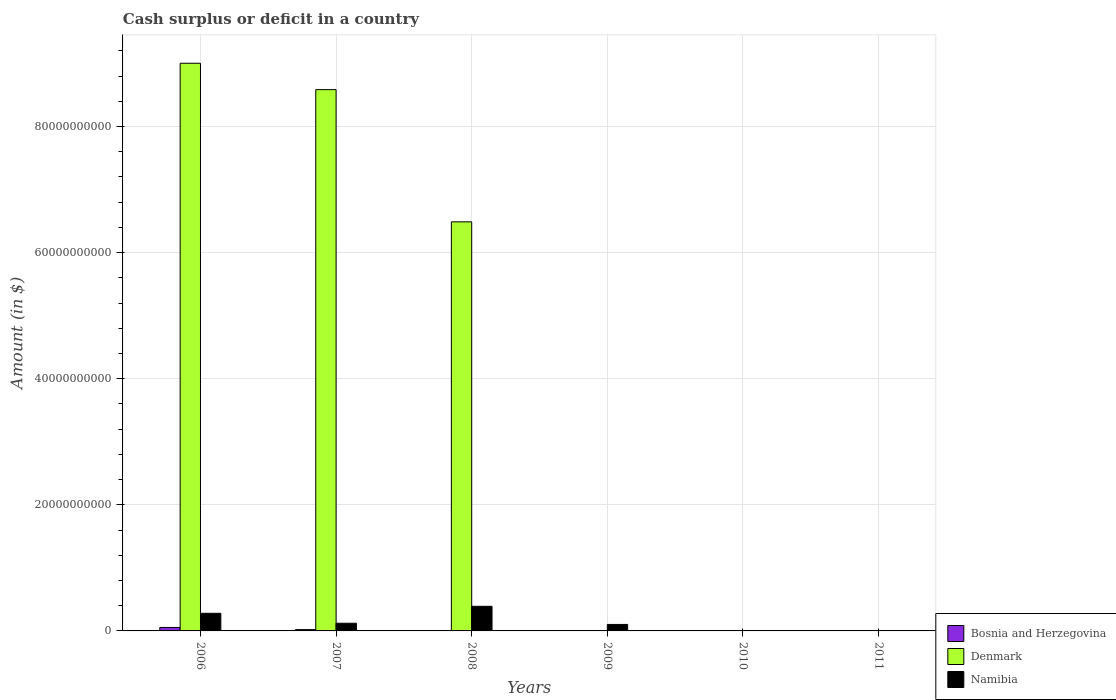How many different coloured bars are there?
Your answer should be compact. 3. Are the number of bars per tick equal to the number of legend labels?
Provide a short and direct response. No. How many bars are there on the 2nd tick from the left?
Make the answer very short. 3. How many bars are there on the 2nd tick from the right?
Your answer should be very brief. 0. In how many cases, is the number of bars for a given year not equal to the number of legend labels?
Provide a succinct answer. 4. What is the amount of cash surplus or deficit in Bosnia and Herzegovina in 2009?
Your response must be concise. 0. Across all years, what is the maximum amount of cash surplus or deficit in Namibia?
Ensure brevity in your answer.  3.90e+09. Across all years, what is the minimum amount of cash surplus or deficit in Denmark?
Ensure brevity in your answer.  0. In which year was the amount of cash surplus or deficit in Denmark maximum?
Your response must be concise. 2006. What is the total amount of cash surplus or deficit in Bosnia and Herzegovina in the graph?
Give a very brief answer. 7.57e+08. What is the difference between the amount of cash surplus or deficit in Denmark in 2006 and that in 2008?
Give a very brief answer. 2.52e+1. What is the difference between the amount of cash surplus or deficit in Namibia in 2008 and the amount of cash surplus or deficit in Bosnia and Herzegovina in 2009?
Your answer should be very brief. 3.90e+09. What is the average amount of cash surplus or deficit in Bosnia and Herzegovina per year?
Keep it short and to the point. 1.26e+08. In the year 2006, what is the difference between the amount of cash surplus or deficit in Namibia and amount of cash surplus or deficit in Bosnia and Herzegovina?
Provide a succinct answer. 2.24e+09. What is the ratio of the amount of cash surplus or deficit in Namibia in 2007 to that in 2009?
Offer a very short reply. 1.18. What is the difference between the highest and the second highest amount of cash surplus or deficit in Denmark?
Offer a terse response. 4.18e+09. What is the difference between the highest and the lowest amount of cash surplus or deficit in Namibia?
Provide a succinct answer. 3.90e+09. In how many years, is the amount of cash surplus or deficit in Denmark greater than the average amount of cash surplus or deficit in Denmark taken over all years?
Offer a very short reply. 3. Is the sum of the amount of cash surplus or deficit in Denmark in 2007 and 2008 greater than the maximum amount of cash surplus or deficit in Bosnia and Herzegovina across all years?
Your answer should be very brief. Yes. Are all the bars in the graph horizontal?
Give a very brief answer. No. How many years are there in the graph?
Make the answer very short. 6. How many legend labels are there?
Offer a terse response. 3. What is the title of the graph?
Provide a short and direct response. Cash surplus or deficit in a country. Does "Latvia" appear as one of the legend labels in the graph?
Provide a short and direct response. No. What is the label or title of the X-axis?
Give a very brief answer. Years. What is the label or title of the Y-axis?
Your answer should be very brief. Amount (in $). What is the Amount (in $) of Bosnia and Herzegovina in 2006?
Your response must be concise. 5.51e+08. What is the Amount (in $) in Denmark in 2006?
Your response must be concise. 9.00e+1. What is the Amount (in $) in Namibia in 2006?
Provide a short and direct response. 2.79e+09. What is the Amount (in $) in Bosnia and Herzegovina in 2007?
Your answer should be compact. 2.07e+08. What is the Amount (in $) in Denmark in 2007?
Offer a very short reply. 8.59e+1. What is the Amount (in $) in Namibia in 2007?
Your response must be concise. 1.22e+09. What is the Amount (in $) in Bosnia and Herzegovina in 2008?
Provide a succinct answer. 0. What is the Amount (in $) in Denmark in 2008?
Your response must be concise. 6.49e+1. What is the Amount (in $) of Namibia in 2008?
Offer a terse response. 3.90e+09. What is the Amount (in $) in Namibia in 2009?
Your answer should be very brief. 1.03e+09. What is the Amount (in $) in Bosnia and Herzegovina in 2010?
Ensure brevity in your answer.  0. What is the Amount (in $) in Namibia in 2010?
Your response must be concise. 0. What is the Amount (in $) in Bosnia and Herzegovina in 2011?
Provide a short and direct response. 0. What is the Amount (in $) in Denmark in 2011?
Give a very brief answer. 0. What is the Amount (in $) in Namibia in 2011?
Keep it short and to the point. 0. Across all years, what is the maximum Amount (in $) of Bosnia and Herzegovina?
Your answer should be compact. 5.51e+08. Across all years, what is the maximum Amount (in $) in Denmark?
Keep it short and to the point. 9.00e+1. Across all years, what is the maximum Amount (in $) of Namibia?
Your response must be concise. 3.90e+09. What is the total Amount (in $) of Bosnia and Herzegovina in the graph?
Offer a terse response. 7.57e+08. What is the total Amount (in $) of Denmark in the graph?
Your answer should be compact. 2.41e+11. What is the total Amount (in $) of Namibia in the graph?
Give a very brief answer. 8.94e+09. What is the difference between the Amount (in $) in Bosnia and Herzegovina in 2006 and that in 2007?
Your answer should be compact. 3.44e+08. What is the difference between the Amount (in $) in Denmark in 2006 and that in 2007?
Your answer should be compact. 4.18e+09. What is the difference between the Amount (in $) of Namibia in 2006 and that in 2007?
Keep it short and to the point. 1.58e+09. What is the difference between the Amount (in $) of Denmark in 2006 and that in 2008?
Ensure brevity in your answer.  2.52e+1. What is the difference between the Amount (in $) of Namibia in 2006 and that in 2008?
Keep it short and to the point. -1.11e+09. What is the difference between the Amount (in $) in Namibia in 2006 and that in 2009?
Give a very brief answer. 1.77e+09. What is the difference between the Amount (in $) in Denmark in 2007 and that in 2008?
Keep it short and to the point. 2.10e+1. What is the difference between the Amount (in $) in Namibia in 2007 and that in 2008?
Make the answer very short. -2.69e+09. What is the difference between the Amount (in $) of Namibia in 2007 and that in 2009?
Your answer should be compact. 1.88e+08. What is the difference between the Amount (in $) in Namibia in 2008 and that in 2009?
Your response must be concise. 2.87e+09. What is the difference between the Amount (in $) in Bosnia and Herzegovina in 2006 and the Amount (in $) in Denmark in 2007?
Your response must be concise. -8.53e+1. What is the difference between the Amount (in $) of Bosnia and Herzegovina in 2006 and the Amount (in $) of Namibia in 2007?
Your response must be concise. -6.66e+08. What is the difference between the Amount (in $) in Denmark in 2006 and the Amount (in $) in Namibia in 2007?
Provide a succinct answer. 8.88e+1. What is the difference between the Amount (in $) in Bosnia and Herzegovina in 2006 and the Amount (in $) in Denmark in 2008?
Provide a succinct answer. -6.43e+1. What is the difference between the Amount (in $) in Bosnia and Herzegovina in 2006 and the Amount (in $) in Namibia in 2008?
Make the answer very short. -3.35e+09. What is the difference between the Amount (in $) of Denmark in 2006 and the Amount (in $) of Namibia in 2008?
Offer a very short reply. 8.61e+1. What is the difference between the Amount (in $) of Bosnia and Herzegovina in 2006 and the Amount (in $) of Namibia in 2009?
Keep it short and to the point. -4.78e+08. What is the difference between the Amount (in $) in Denmark in 2006 and the Amount (in $) in Namibia in 2009?
Provide a short and direct response. 8.90e+1. What is the difference between the Amount (in $) of Bosnia and Herzegovina in 2007 and the Amount (in $) of Denmark in 2008?
Give a very brief answer. -6.47e+1. What is the difference between the Amount (in $) in Bosnia and Herzegovina in 2007 and the Amount (in $) in Namibia in 2008?
Give a very brief answer. -3.70e+09. What is the difference between the Amount (in $) in Denmark in 2007 and the Amount (in $) in Namibia in 2008?
Provide a short and direct response. 8.20e+1. What is the difference between the Amount (in $) in Bosnia and Herzegovina in 2007 and the Amount (in $) in Namibia in 2009?
Your answer should be compact. -8.22e+08. What is the difference between the Amount (in $) in Denmark in 2007 and the Amount (in $) in Namibia in 2009?
Ensure brevity in your answer.  8.48e+1. What is the difference between the Amount (in $) in Denmark in 2008 and the Amount (in $) in Namibia in 2009?
Provide a short and direct response. 6.39e+1. What is the average Amount (in $) in Bosnia and Herzegovina per year?
Keep it short and to the point. 1.26e+08. What is the average Amount (in $) in Denmark per year?
Ensure brevity in your answer.  4.01e+1. What is the average Amount (in $) of Namibia per year?
Your answer should be compact. 1.49e+09. In the year 2006, what is the difference between the Amount (in $) of Bosnia and Herzegovina and Amount (in $) of Denmark?
Offer a very short reply. -8.95e+1. In the year 2006, what is the difference between the Amount (in $) of Bosnia and Herzegovina and Amount (in $) of Namibia?
Provide a short and direct response. -2.24e+09. In the year 2006, what is the difference between the Amount (in $) in Denmark and Amount (in $) in Namibia?
Your answer should be compact. 8.72e+1. In the year 2007, what is the difference between the Amount (in $) in Bosnia and Herzegovina and Amount (in $) in Denmark?
Make the answer very short. -8.57e+1. In the year 2007, what is the difference between the Amount (in $) of Bosnia and Herzegovina and Amount (in $) of Namibia?
Offer a very short reply. -1.01e+09. In the year 2007, what is the difference between the Amount (in $) of Denmark and Amount (in $) of Namibia?
Offer a very short reply. 8.46e+1. In the year 2008, what is the difference between the Amount (in $) of Denmark and Amount (in $) of Namibia?
Offer a terse response. 6.10e+1. What is the ratio of the Amount (in $) in Bosnia and Herzegovina in 2006 to that in 2007?
Offer a very short reply. 2.66. What is the ratio of the Amount (in $) in Denmark in 2006 to that in 2007?
Provide a succinct answer. 1.05. What is the ratio of the Amount (in $) of Namibia in 2006 to that in 2007?
Your response must be concise. 2.3. What is the ratio of the Amount (in $) of Denmark in 2006 to that in 2008?
Your answer should be very brief. 1.39. What is the ratio of the Amount (in $) of Namibia in 2006 to that in 2008?
Offer a very short reply. 0.72. What is the ratio of the Amount (in $) of Namibia in 2006 to that in 2009?
Your response must be concise. 2.72. What is the ratio of the Amount (in $) of Denmark in 2007 to that in 2008?
Make the answer very short. 1.32. What is the ratio of the Amount (in $) in Namibia in 2007 to that in 2008?
Provide a short and direct response. 0.31. What is the ratio of the Amount (in $) in Namibia in 2007 to that in 2009?
Offer a very short reply. 1.18. What is the ratio of the Amount (in $) in Namibia in 2008 to that in 2009?
Your answer should be compact. 3.79. What is the difference between the highest and the second highest Amount (in $) in Denmark?
Your answer should be very brief. 4.18e+09. What is the difference between the highest and the second highest Amount (in $) of Namibia?
Offer a very short reply. 1.11e+09. What is the difference between the highest and the lowest Amount (in $) of Bosnia and Herzegovina?
Keep it short and to the point. 5.51e+08. What is the difference between the highest and the lowest Amount (in $) of Denmark?
Your answer should be very brief. 9.00e+1. What is the difference between the highest and the lowest Amount (in $) in Namibia?
Keep it short and to the point. 3.90e+09. 